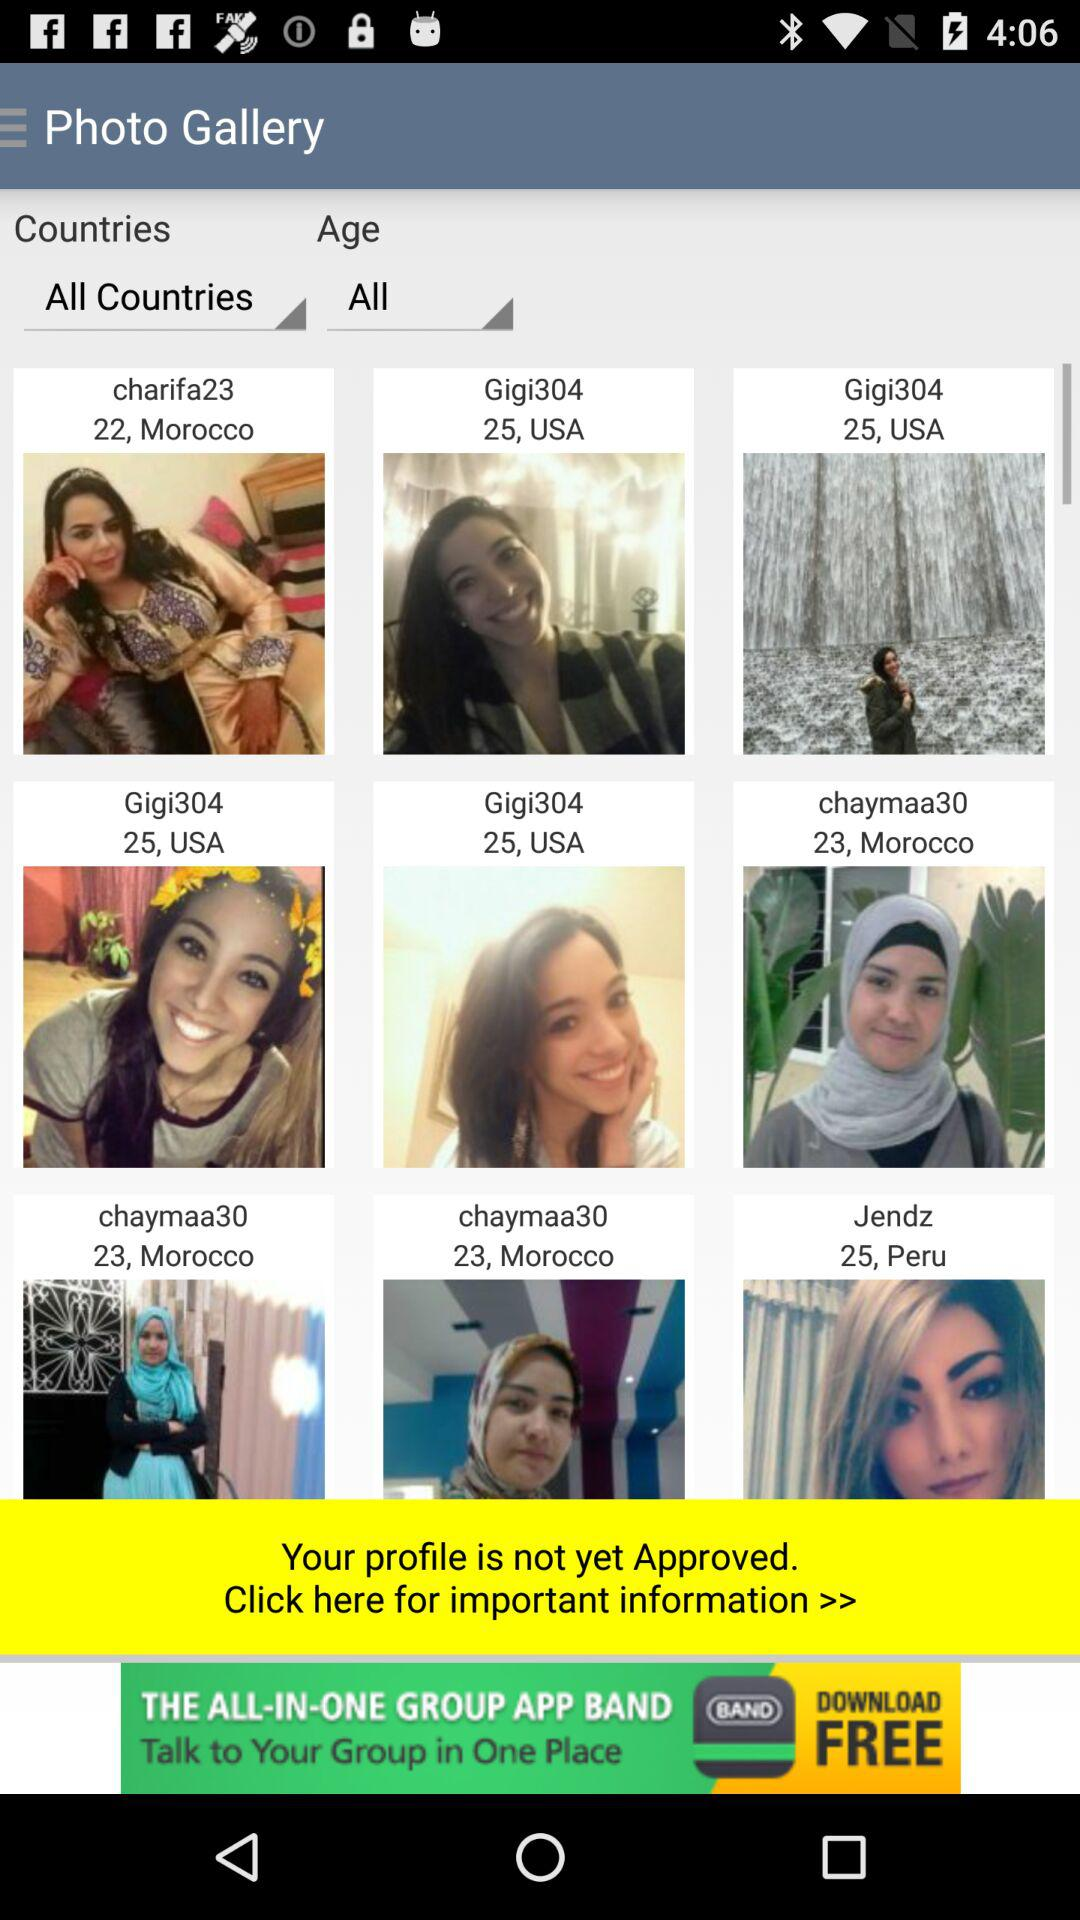What is the age of "Gigi304"? The age of "Gigi304" is 25 years. 